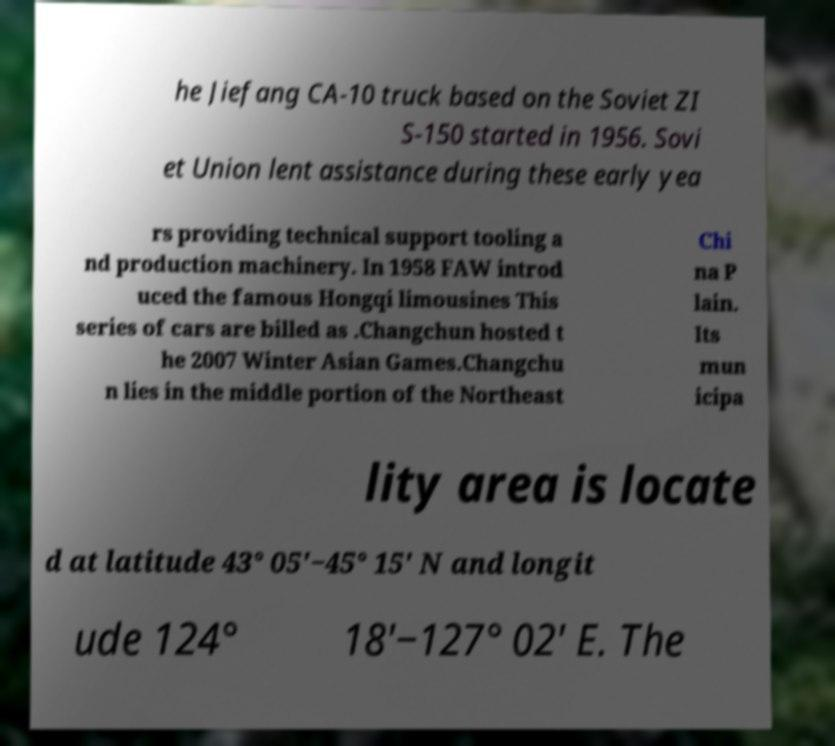Can you read and provide the text displayed in the image?This photo seems to have some interesting text. Can you extract and type it out for me? he Jiefang CA-10 truck based on the Soviet ZI S-150 started in 1956. Sovi et Union lent assistance during these early yea rs providing technical support tooling a nd production machinery. In 1958 FAW introd uced the famous Hongqi limousines This series of cars are billed as .Changchun hosted t he 2007 Winter Asian Games.Changchu n lies in the middle portion of the Northeast Chi na P lain. Its mun icipa lity area is locate d at latitude 43° 05′−45° 15′ N and longit ude 124° 18′−127° 02' E. The 